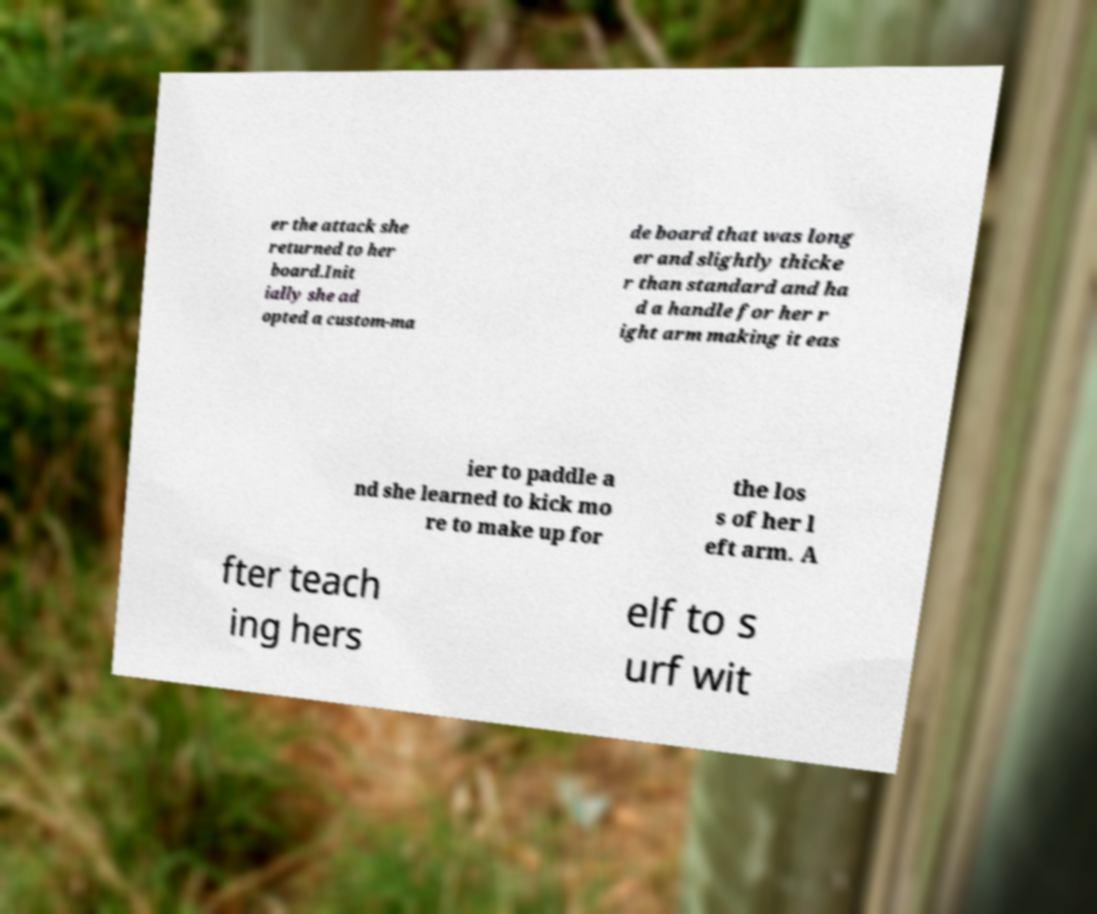There's text embedded in this image that I need extracted. Can you transcribe it verbatim? er the attack she returned to her board.Init ially she ad opted a custom-ma de board that was long er and slightly thicke r than standard and ha d a handle for her r ight arm making it eas ier to paddle a nd she learned to kick mo re to make up for the los s of her l eft arm. A fter teach ing hers elf to s urf wit 